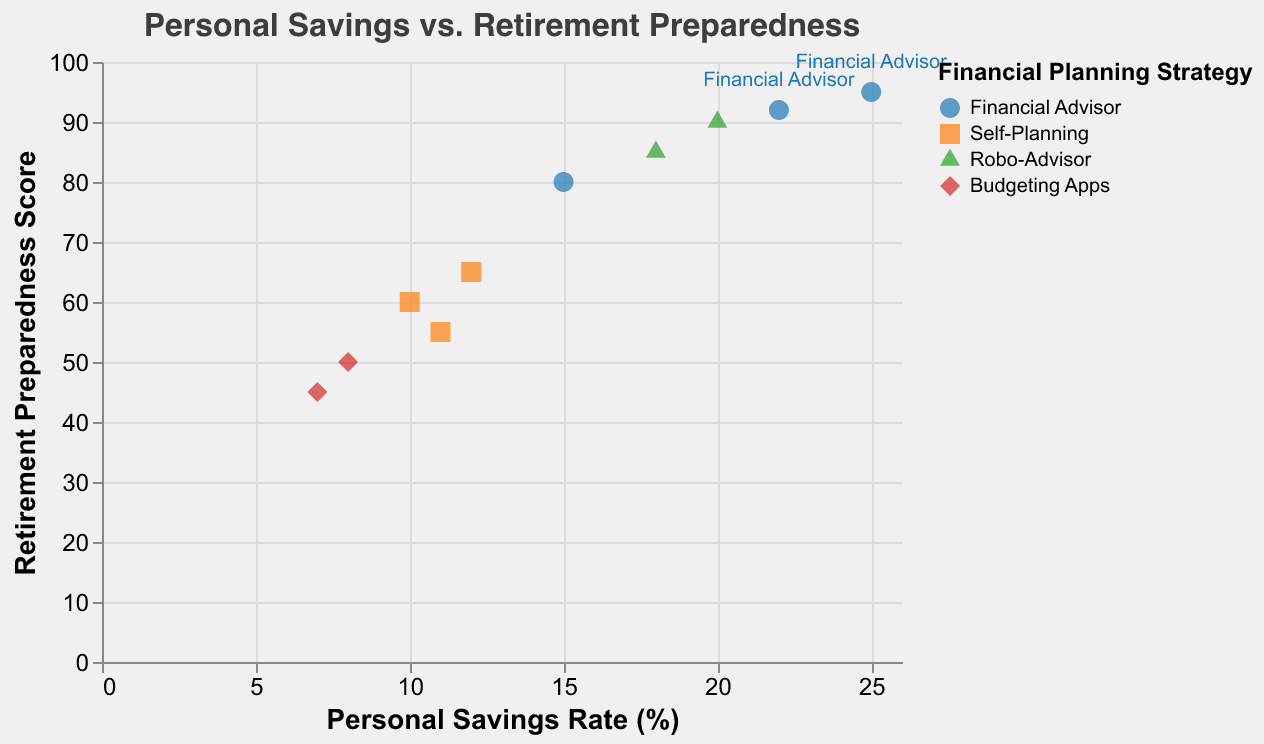What is the title of the scatter plot? The title is displayed at the top of the plot and reads "Personal Savings vs. Retirement Preparedness".
Answer: Personal Savings vs. Retirement Preparedness How many different financial planning strategies are represented in the plot? The legend shows four distinct financial planning strategies. Each strategy is represented by a unique color and shape.
Answer: Four Which financial planning strategy appears to have the highest retirement preparedness score? Reviewing the data points, "Financial Advisor" has a point at the highest vertical position on the plot with a preparedness score of 95.
Answer: Financial Advisor Compare the personal savings rates for the "Robo-Advisor" strategy. Which rate is higher? There are two data points for "Robo-Advisor" with savings rates of 20% and 18%. The 20% rate is higher.
Answer: 20% What's the average retirement preparedness score for the "Self-Planning" strategy? There are three data points for "Self-Planning" with scores of 60, 65, and 55. The sum is 180, and the average is 180/3.
Answer: 60 Which strategy shows the lowest retirement preparedness score, and what is the corresponding personal savings rate? "Budgeting Apps" has the lowest preparedness score of 45, and the corresponding savings rate is 7%.
Answer: Budgeting Apps, 7% Based on the plot, does a higher personal savings rate always correlate with a higher retirement preparedness score? There are some instances, such as 15% and 25% savings rates for "Financial Advisor", with corresponding preparedness scores of 80 and 95, but not all points show a direct correlation (e.g., 10% savings rate with 60 preparedness). Thus, it's not always consistent.
Answer: No What is the range of personal savings rates for the "Financial Advisor" strategy? The personal savings rates for "Financial Advisor" range from 15% to 25%.
Answer: 10% Which financial planning strategy appears to have the most consistent retirement preparedness scores? By observing the vertical spread of data points, "Financial Advisor" seems to have the most compact spread in the higher preparedness score range (80 to 95).
Answer: Financial Advisor How does the retirement preparedness score for "Self-Planning" at 12% personal savings rate compare to that of "Budgeting Apps" at 8% rate? The retirement preparedness score for "Self-Planning" at 12% savings rate is 65, which is higher than "Budgeting Apps" at 8% savings rate, which has a score of 50.
Answer: Higher 